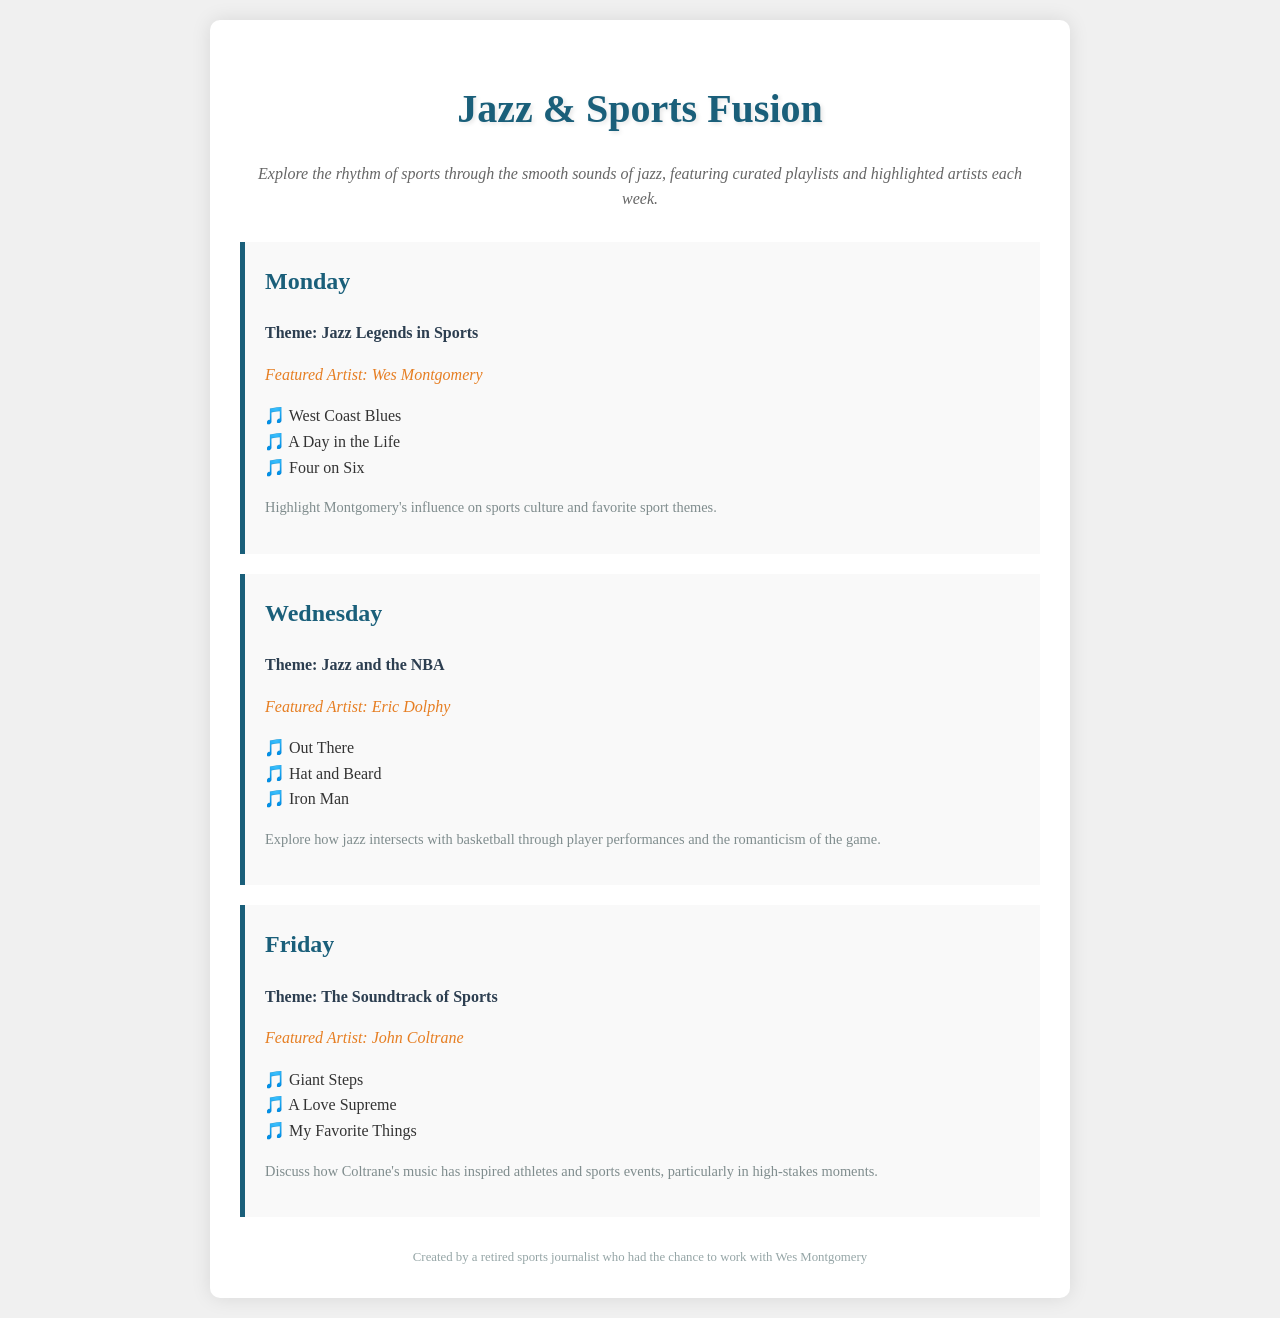What is the theme for Monday? The theme for Monday is stated in the document under the Monday schedule.
Answer: Jazz Legends in Sports Who is the featured artist on Wednesday? The document lists the featured artist for each day; for Wednesday, it is Eric Dolphy.
Answer: Eric Dolphy What is one song listed for the featured artist on Monday? The songs performed by Wes Montgomery are listed in the Monday schedule.
Answer: West Coast Blues How many songs are listed for John Coltrane? The number of songs for each featured artist can be counted in the Friday schedule.
Answer: Three What is the primary sport theme discussed on Wednesday? The document describes the theme related to basketball under the Wednesday segment.
Answer: NBA Who is the featured artist for Friday? The document specifies the featured artist for Friday as John Coltrane.
Answer: John Coltrane What unique perspective does the schedule provide? The schedule aims to explore the intersection of music and sports.
Answer: Jazz & Sports Fusion What do the notes for Monday emphasize? The notes under each day's schedule reveal the key focus or message for that day; Monday emphasizes Montgomery's influence.
Answer: Montgomery's influence on sports culture 